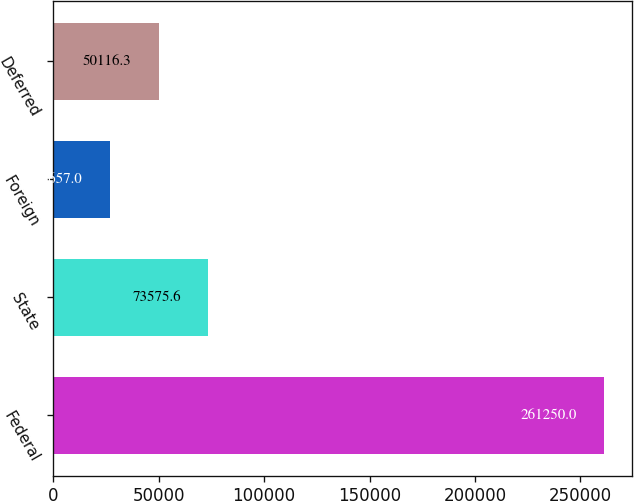<chart> <loc_0><loc_0><loc_500><loc_500><bar_chart><fcel>Federal<fcel>State<fcel>Foreign<fcel>Deferred<nl><fcel>261250<fcel>73575.6<fcel>26657<fcel>50116.3<nl></chart> 